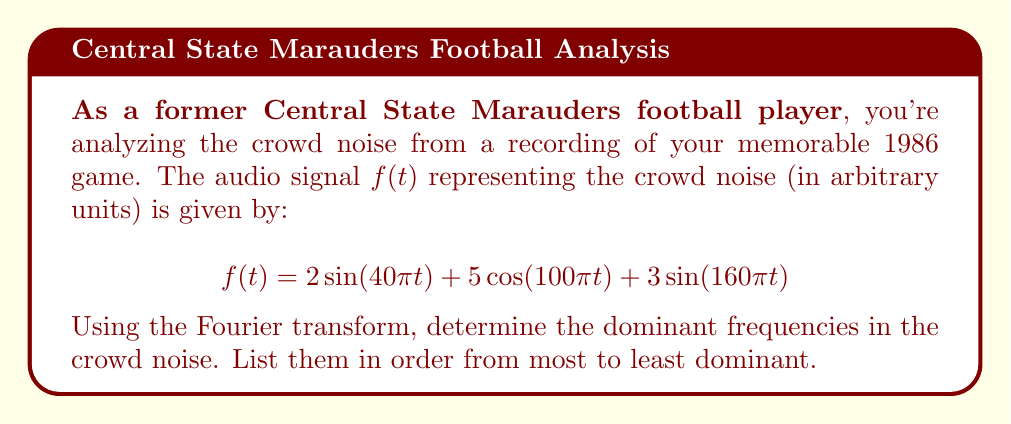What is the answer to this math problem? To find the dominant frequencies, we need to analyze the given function $f(t)$ in the frequency domain using the Fourier transform. Here's the step-by-step process:

1) First, recall that for sinusoidal functions, the frequency $f$ is related to the angular frequency $\omega$ by the equation:

   $$f = \frac{\omega}{2\pi}$$

2) Now, let's identify the angular frequencies in each term:

   - $2\sin(40\pi t)$: $\omega_1 = 40\pi$
   - $5\cos(100\pi t)$: $\omega_2 = 100\pi$
   - $3\sin(160\pi t)$: $\omega_3 = 160\pi$

3) Convert these angular frequencies to regular frequencies:

   - $f_1 = \frac{40\pi}{2\pi} = 20$ Hz
   - $f_2 = \frac{100\pi}{2\pi} = 50$ Hz
   - $f_3 = \frac{160\pi}{2\pi} = 80$ Hz

4) The amplitude of each term represents its contribution to the overall signal:

   - 20 Hz: amplitude of 2
   - 50 Hz: amplitude of 5
   - 80 Hz: amplitude of 3

5) Ordering these from most dominant (highest amplitude) to least:

   50 Hz (amplitude 5) > 80 Hz (amplitude 3) > 20 Hz (amplitude 2)

Therefore, the dominant frequencies in order are 50 Hz, 80 Hz, and 20 Hz.
Answer: 50 Hz, 80 Hz, 20 Hz 